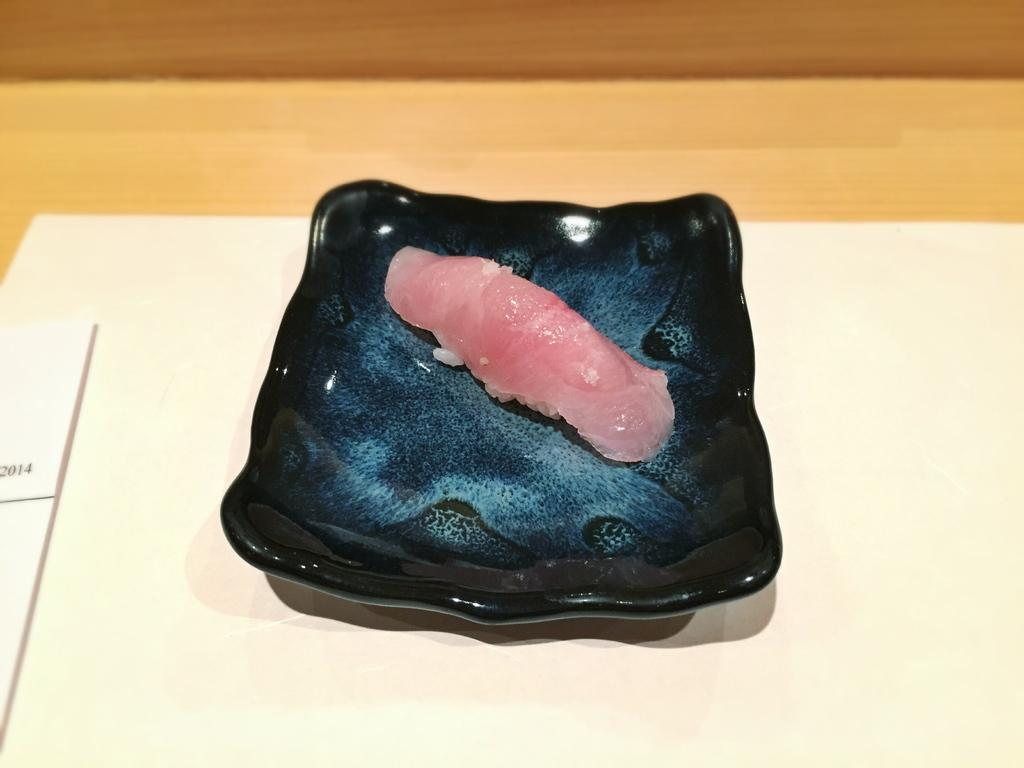What is on the plate that is visible in the image? There is a plate with meat on it in the image. What is the color of the plate? The plate is black in color. What is the plate placed on? The plate is placed on a white tray. Where is the tray located? The tray is placed on a table. What else can be seen on the table? There is a paper on the table. What type of amusement can be seen on the plate in the image? There is no amusement present on the plate in the image; it contains meat. 